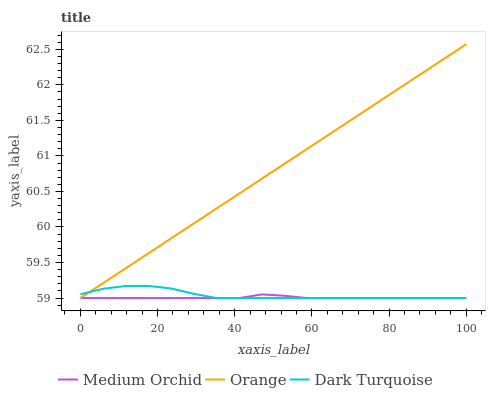Does Medium Orchid have the minimum area under the curve?
Answer yes or no. Yes. Does Orange have the maximum area under the curve?
Answer yes or no. Yes. Does Dark Turquoise have the minimum area under the curve?
Answer yes or no. No. Does Dark Turquoise have the maximum area under the curve?
Answer yes or no. No. Is Orange the smoothest?
Answer yes or no. Yes. Is Dark Turquoise the roughest?
Answer yes or no. Yes. Is Medium Orchid the smoothest?
Answer yes or no. No. Is Medium Orchid the roughest?
Answer yes or no. No. Does Orange have the highest value?
Answer yes or no. Yes. Does Dark Turquoise have the highest value?
Answer yes or no. No. Does Orange intersect Medium Orchid?
Answer yes or no. Yes. Is Orange less than Medium Orchid?
Answer yes or no. No. Is Orange greater than Medium Orchid?
Answer yes or no. No. 